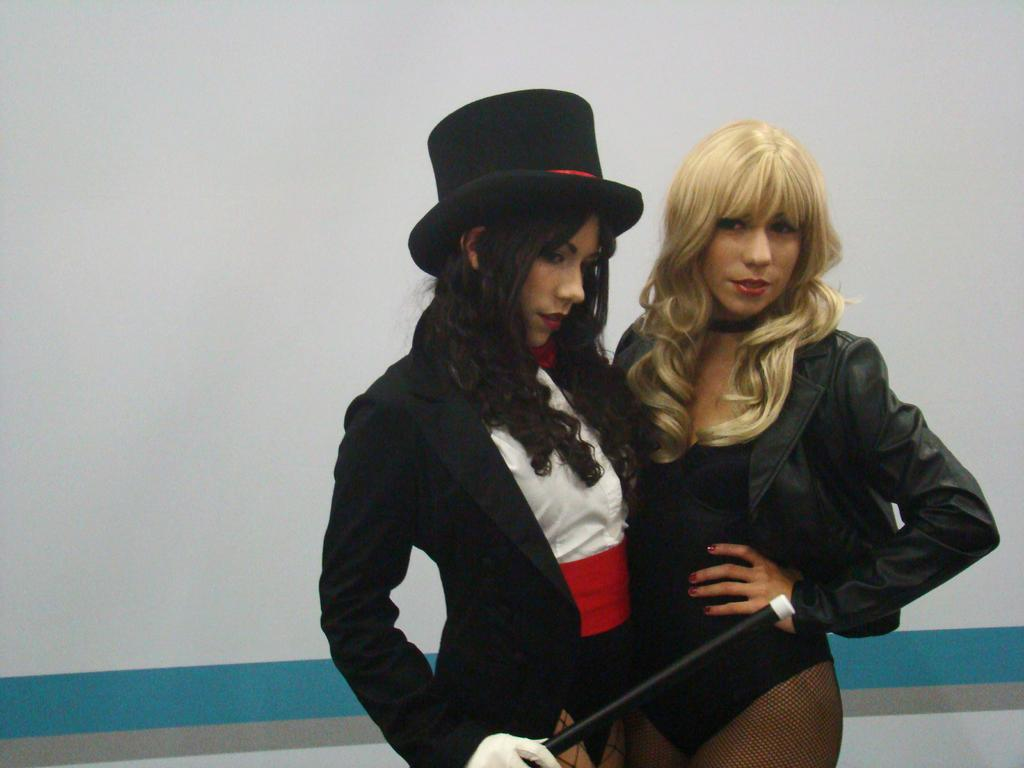How many people are in the image? There are two persons standing in the image. What is the person on the left side of the image wearing? The person on the left side of the image is wearing a hat. What is the person wearing a hat holding in their hand? The person wearing a hat is holding a stick in one hand. What can be seen in the background of the image? There is a wall visible in the background of the image. What time is displayed on the clock in the image? There is no clock present in the image. What type of lace is being used to decorate the train in the image? There is no train or lace present in the image. 